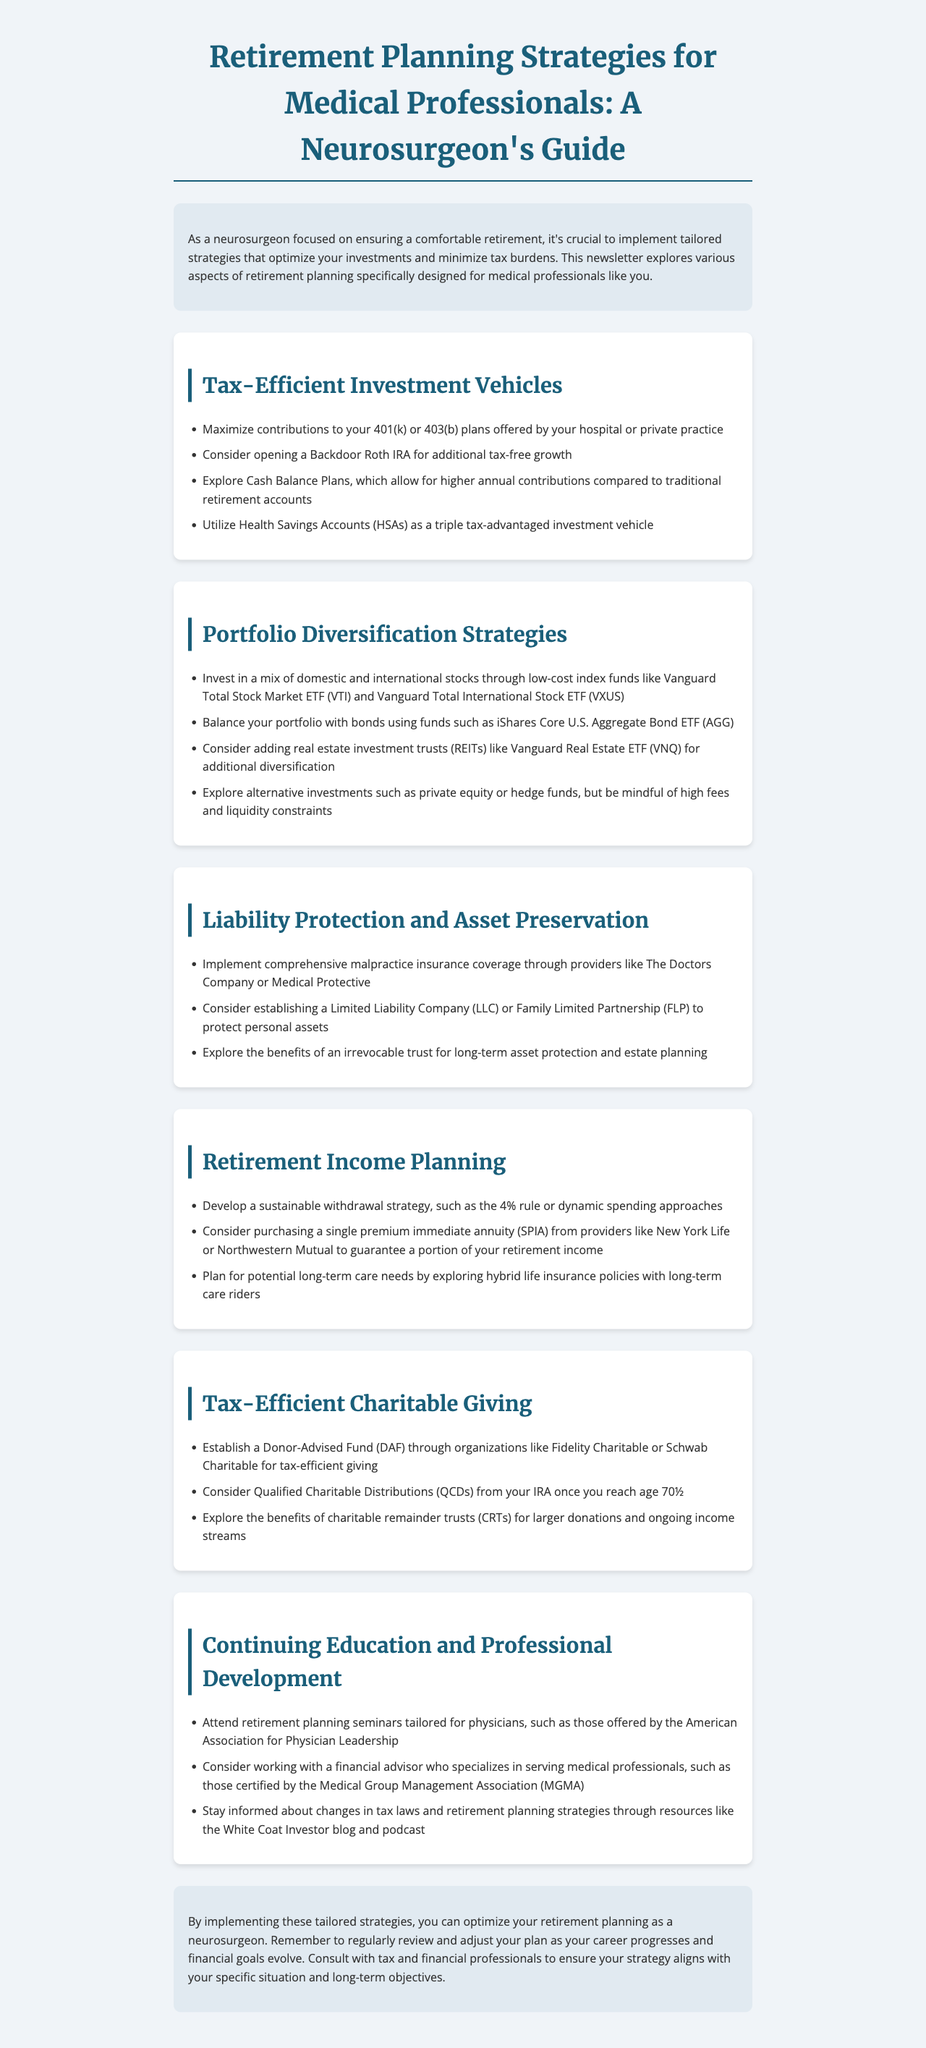What is the newsletter title? The newsletter title is stated at the top of the document.
Answer: Retirement Planning Strategies for Medical Professionals: A Neurosurgeon's Guide What tax-efficient investment vehicle allows for higher annual contributions? This is mentioned under the Tax-Efficient Investment Vehicles section.
Answer: Cash Balance Plans Which index fund is recommended for domestic stock investment? This information is in the Portfolio Diversification Strategies section.
Answer: Vanguard Total Stock Market ETF (VTI) What is a recommended strategy for sustainable withdrawals in retirement? This is found in the Retirement Income Planning section.
Answer: 4% rule What type of insurance is suggested for liability protection? The recommended insurance is mentioned in the Liability Protection and Asset Preservation section.
Answer: Malpractice insurance What organization offers retirement planning seminars tailored for physicians? This can be found in the Continuing Education and Professional Development section.
Answer: American Association for Physician Leadership Which tax-efficient charitable vehicle allows for ongoing income streams? This is discussed in the Tax-Efficient Charitable Giving section.
Answer: Charitable remainder trusts (CRTs) What is the target audience for the newsletter's strategies? The introduction defines the audience.
Answer: Medical professionals like you 